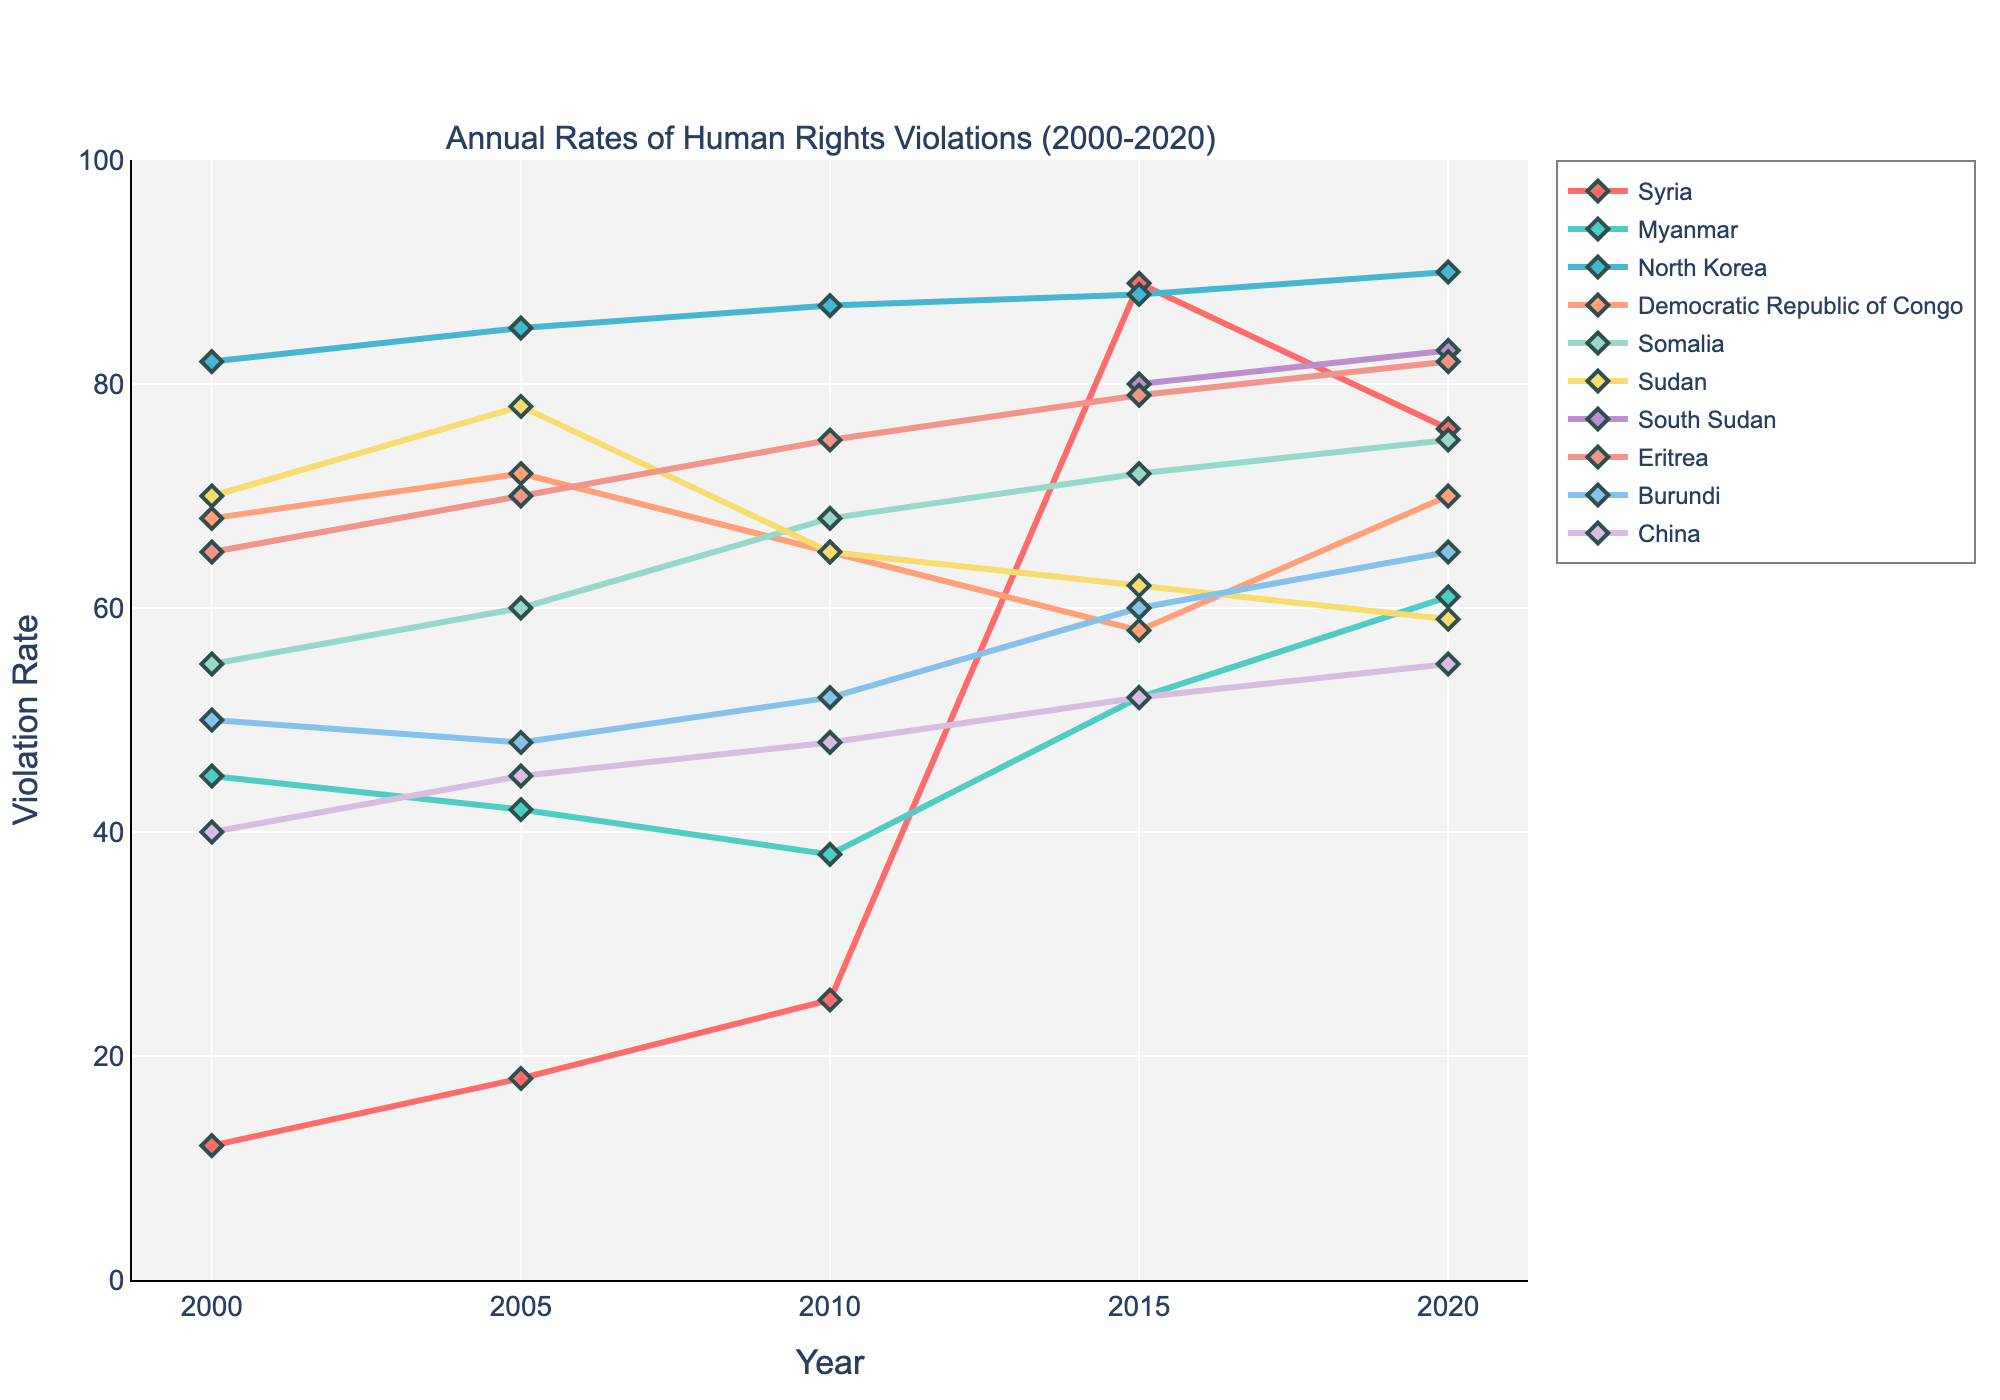Which country experienced the highest rate of human rights violations in 2020? To find the country with the highest violation rate in 2020, we look at the rates for all countries in that year. North Korea has the highest rate of 90.
Answer: North Korea Between 2000 and 2020, which country showed the most significant increase in human rights violation rates? Observe the change in violation rates from 2000 to 2020 for each country. Syria's rate increased from 12 to 76, which is the largest increase of 64.
Answer: Syria In 2015, which countries have similar violation rates around 80? By examining the 2015 data points, South Sudan (80) and Eritrea (79) have violation rates around 80.
Answer: South Sudan and Eritrea What is the average violation rate for Sudan between 2000 and 2020? To compute the average: sum the rates (70+78+65+62+59) and divide by 5. This results in (334/5) which equals 66.8.
Answer: 66.8 Which country showed a decrease in violation rates between 2000 and 2020? Comparing the 2000 and 2020 values, Sudan's rates decreased from 70 to 59, indicating a decrease.
Answer: Sudan Among the listed countries, which one had the lowest rates in 2000? The lowest rate in 2000 visible in the chart is Syria, with a rate of 12.
Answer: Syria From 2005 to 2010, which country experienced the most significant drop in violation rates? Compare the rates for each country between 2005 and 2010, Sudan shows the largest drop from 78 to 65.
Answer: Sudan In 2020, classify the countries into two groups: those with violation rates above 70 and those with rates below 70. Grouping by violation rates in 2020: Above 70: Syria, North Korea, Somalia, South Sudan, Eritrea, Burundi. Below 70: Myanmar, DRC, Sudan, China.
Answer: Above 70: Syria, North Korea, Somalia, South Sudan, Eritrea, Burundi; Below 70: Myanmar, DRC, Sudan, China Comparing Myanmar and Burundi from 2005 to 2020, which country had a more stable trend? From 2005 to 2020, Myanmar showed relatively less fluctuation compared to Burundi, which had a more noticeable upward trend.
Answer: Myanmar 